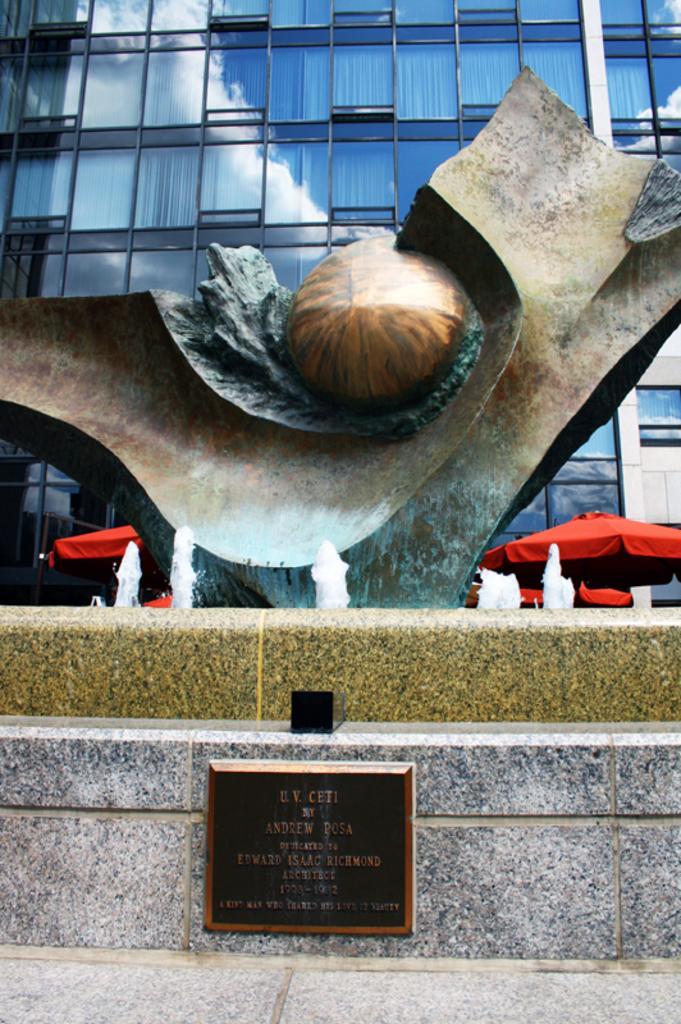Could you give a brief overview of what you see in this image? In this image, we can see a sculpture in the fountain. There is a stone plate at the bottom of the image. There is a building and umbrellas in the middle of the image. 